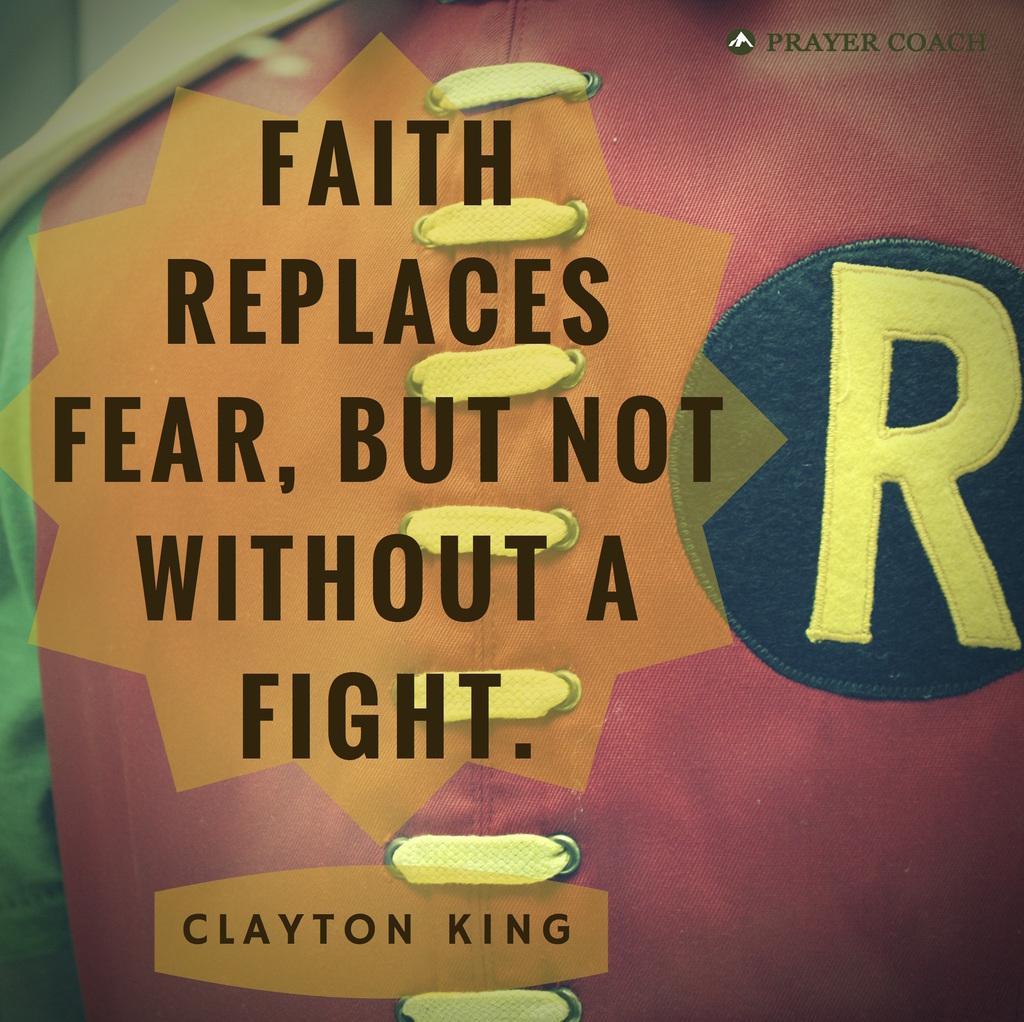What is the color of the text on the poster? The poster contains black color texts. Are there any other colors used for the text on the poster? Yes, there is a yellow color letter on the poster. What else can be found on the poster besides the text? The poster contains other designs. What is the color of the background on the poster? The background of the poster is pink in color. What type of board game is being played in the image? There is no board game present in the image; it features a poster with text and designs. Can you describe the battle scene depicted on the poster? There is no battle scene depicted on the poster; it contains text, designs, and a pink background. 